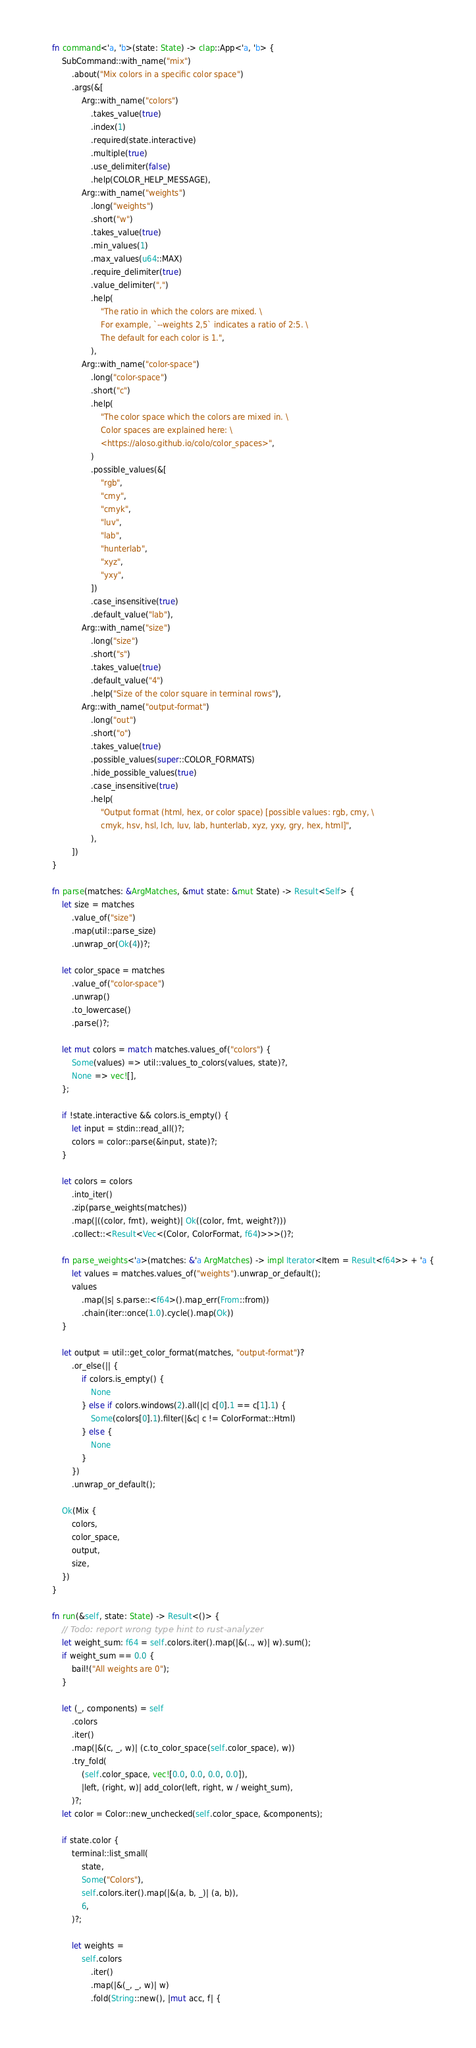Convert code to text. <code><loc_0><loc_0><loc_500><loc_500><_Rust_>    fn command<'a, 'b>(state: State) -> clap::App<'a, 'b> {
        SubCommand::with_name("mix")
            .about("Mix colors in a specific color space")
            .args(&[
                Arg::with_name("colors")
                    .takes_value(true)
                    .index(1)
                    .required(state.interactive)
                    .multiple(true)
                    .use_delimiter(false)
                    .help(COLOR_HELP_MESSAGE),
                Arg::with_name("weights")
                    .long("weights")
                    .short("w")
                    .takes_value(true)
                    .min_values(1)
                    .max_values(u64::MAX)
                    .require_delimiter(true)
                    .value_delimiter(",")
                    .help(
                        "The ratio in which the colors are mixed. \
                        For example, `--weights 2,5` indicates a ratio of 2:5. \
                        The default for each color is 1.",
                    ),
                Arg::with_name("color-space")
                    .long("color-space")
                    .short("c")
                    .help(
                        "The color space which the colors are mixed in. \
                        Color spaces are explained here: \
                        <https://aloso.github.io/colo/color_spaces>",
                    )
                    .possible_values(&[
                        "rgb",
                        "cmy",
                        "cmyk",
                        "luv",
                        "lab",
                        "hunterlab",
                        "xyz",
                        "yxy",
                    ])
                    .case_insensitive(true)
                    .default_value("lab"),
                Arg::with_name("size")
                    .long("size")
                    .short("s")
                    .takes_value(true)
                    .default_value("4")
                    .help("Size of the color square in terminal rows"),
                Arg::with_name("output-format")
                    .long("out")
                    .short("o")
                    .takes_value(true)
                    .possible_values(super::COLOR_FORMATS)
                    .hide_possible_values(true)
                    .case_insensitive(true)
                    .help(
                        "Output format (html, hex, or color space) [possible values: rgb, cmy, \
                        cmyk, hsv, hsl, lch, luv, lab, hunterlab, xyz, yxy, gry, hex, html]",
                    ),
            ])
    }

    fn parse(matches: &ArgMatches, &mut state: &mut State) -> Result<Self> {
        let size = matches
            .value_of("size")
            .map(util::parse_size)
            .unwrap_or(Ok(4))?;

        let color_space = matches
            .value_of("color-space")
            .unwrap()
            .to_lowercase()
            .parse()?;

        let mut colors = match matches.values_of("colors") {
            Some(values) => util::values_to_colors(values, state)?,
            None => vec![],
        };

        if !state.interactive && colors.is_empty() {
            let input = stdin::read_all()?;
            colors = color::parse(&input, state)?;
        }

        let colors = colors
            .into_iter()
            .zip(parse_weights(matches))
            .map(|((color, fmt), weight)| Ok((color, fmt, weight?)))
            .collect::<Result<Vec<(Color, ColorFormat, f64)>>>()?;

        fn parse_weights<'a>(matches: &'a ArgMatches) -> impl Iterator<Item = Result<f64>> + 'a {
            let values = matches.values_of("weights").unwrap_or_default();
            values
                .map(|s| s.parse::<f64>().map_err(From::from))
                .chain(iter::once(1.0).cycle().map(Ok))
        }

        let output = util::get_color_format(matches, "output-format")?
            .or_else(|| {
                if colors.is_empty() {
                    None
                } else if colors.windows(2).all(|c| c[0].1 == c[1].1) {
                    Some(colors[0].1).filter(|&c| c != ColorFormat::Html)
                } else {
                    None
                }
            })
            .unwrap_or_default();

        Ok(Mix {
            colors,
            color_space,
            output,
            size,
        })
    }

    fn run(&self, state: State) -> Result<()> {
        // Todo: report wrong type hint to rust-analyzer
        let weight_sum: f64 = self.colors.iter().map(|&(.., w)| w).sum();
        if weight_sum == 0.0 {
            bail!("All weights are 0");
        }

        let (_, components) = self
            .colors
            .iter()
            .map(|&(c, _, w)| (c.to_color_space(self.color_space), w))
            .try_fold(
                (self.color_space, vec![0.0, 0.0, 0.0, 0.0]),
                |left, (right, w)| add_color(left, right, w / weight_sum),
            )?;
        let color = Color::new_unchecked(self.color_space, &components);

        if state.color {
            terminal::list_small(
                state,
                Some("Colors"),
                self.colors.iter().map(|&(a, b, _)| (a, b)),
                6,
            )?;

            let weights =
                self.colors
                    .iter()
                    .map(|&(_, _, w)| w)
                    .fold(String::new(), |mut acc, f| {</code> 